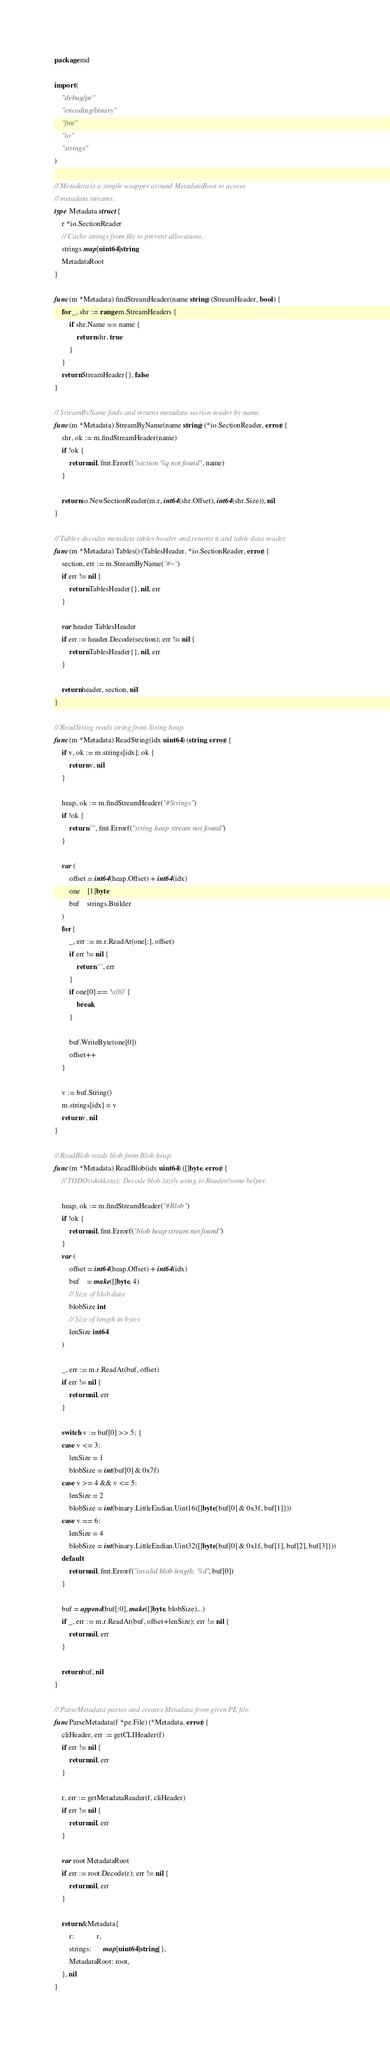Convert code to text. <code><loc_0><loc_0><loc_500><loc_500><_Go_>package md

import (
	"debug/pe"
	"encoding/binary"
	"fmt"
	"io"
	"strings"
)

// Metadata is a simple wrapper around MetadataRoot to access
// metadata streams.
type Metadata struct {
	r *io.SectionReader
	// Cache strings from file to prevent allocations.
	strings map[uint64]string
	MetadataRoot
}

func (m *Metadata) findStreamHeader(name string) (StreamHeader, bool) {
	for _, shr := range m.StreamHeaders {
		if shr.Name == name {
			return shr, true
		}
	}
	return StreamHeader{}, false
}

// StreamByName finds and returns metadata section reader by name.
func (m *Metadata) StreamByName(name string) (*io.SectionReader, error) {
	shr, ok := m.findStreamHeader(name)
	if !ok {
		return nil, fmt.Errorf("section %q not found", name)
	}

	return io.NewSectionReader(m.r, int64(shr.Offset), int64(shr.Size)), nil
}

// Tables decodes metadata tables header and returns it and table data reader.
func (m *Metadata) Tables() (TablesHeader, *io.SectionReader, error) {
	section, err := m.StreamByName("#~")
	if err != nil {
		return TablesHeader{}, nil, err
	}

	var header TablesHeader
	if err := header.Decode(section); err != nil {
		return TablesHeader{}, nil, err
	}

	return header, section, nil
}

// ReadString reads string from String heap.
func (m *Metadata) ReadString(idx uint64) (string, error) {
	if v, ok := m.strings[idx]; ok {
		return v, nil
	}

	heap, ok := m.findStreamHeader("#Strings")
	if !ok {
		return "", fmt.Errorf("string heap stream not found")
	}

	var (
		offset = int64(heap.Offset) + int64(idx)
		one    [1]byte
		buf    strings.Builder
	)
	for {
		_, err := m.r.ReadAt(one[:], offset)
		if err != nil {
			return "", err
		}
		if one[0] == '\x00' {
			break
		}

		buf.WriteByte(one[0])
		offset++
	}

	v := buf.String()
	m.strings[idx] = v
	return v, nil
}

// ReadBlob reads blob from Blob heap.
func (m *Metadata) ReadBlob(idx uint64) ([]byte, error) {
	// TODO(tdakkota): Decode blob lazily using io.Reader/some helper.

	heap, ok := m.findStreamHeader("#Blob")
	if !ok {
		return nil, fmt.Errorf("blob heap stream not found")
	}
	var (
		offset = int64(heap.Offset) + int64(idx)
		buf    = make([]byte, 4)
		// Size of blob data
		blobSize int
		// Size of length in bytes
		lenSize int64
	)

	_, err := m.r.ReadAt(buf, offset)
	if err != nil {
		return nil, err
	}

	switch v := buf[0] >> 5; {
	case v <= 3:
		lenSize = 1
		blobSize = int(buf[0] & 0x7f)
	case v >= 4 && v <= 5:
		lenSize = 2
		blobSize = int(binary.LittleEndian.Uint16([]byte{buf[0] & 0x3f, buf[1]}))
	case v == 6:
		lenSize = 4
		blobSize = int(binary.LittleEndian.Uint32([]byte{buf[0] & 0x1f, buf[1], buf[2], buf[3]}))
	default:
		return nil, fmt.Errorf("invalid blob length: %d", buf[0])
	}

	buf = append(buf[:0], make([]byte, blobSize)...)
	if _, err := m.r.ReadAt(buf, offset+lenSize); err != nil {
		return nil, err
	}

	return buf, nil
}

// ParseMetadata parses and creates Metadata from given PE file.
func ParseMetadata(f *pe.File) (*Metadata, error) {
	cliHeader, err := getCLIHeader(f)
	if err != nil {
		return nil, err
	}

	r, err := getMetadataReader(f, cliHeader)
	if err != nil {
		return nil, err
	}

	var root MetadataRoot
	if err := root.Decode(r); err != nil {
		return nil, err
	}

	return &Metadata{
		r:            r,
		strings:      map[uint64]string{},
		MetadataRoot: root,
	}, nil
}
</code> 